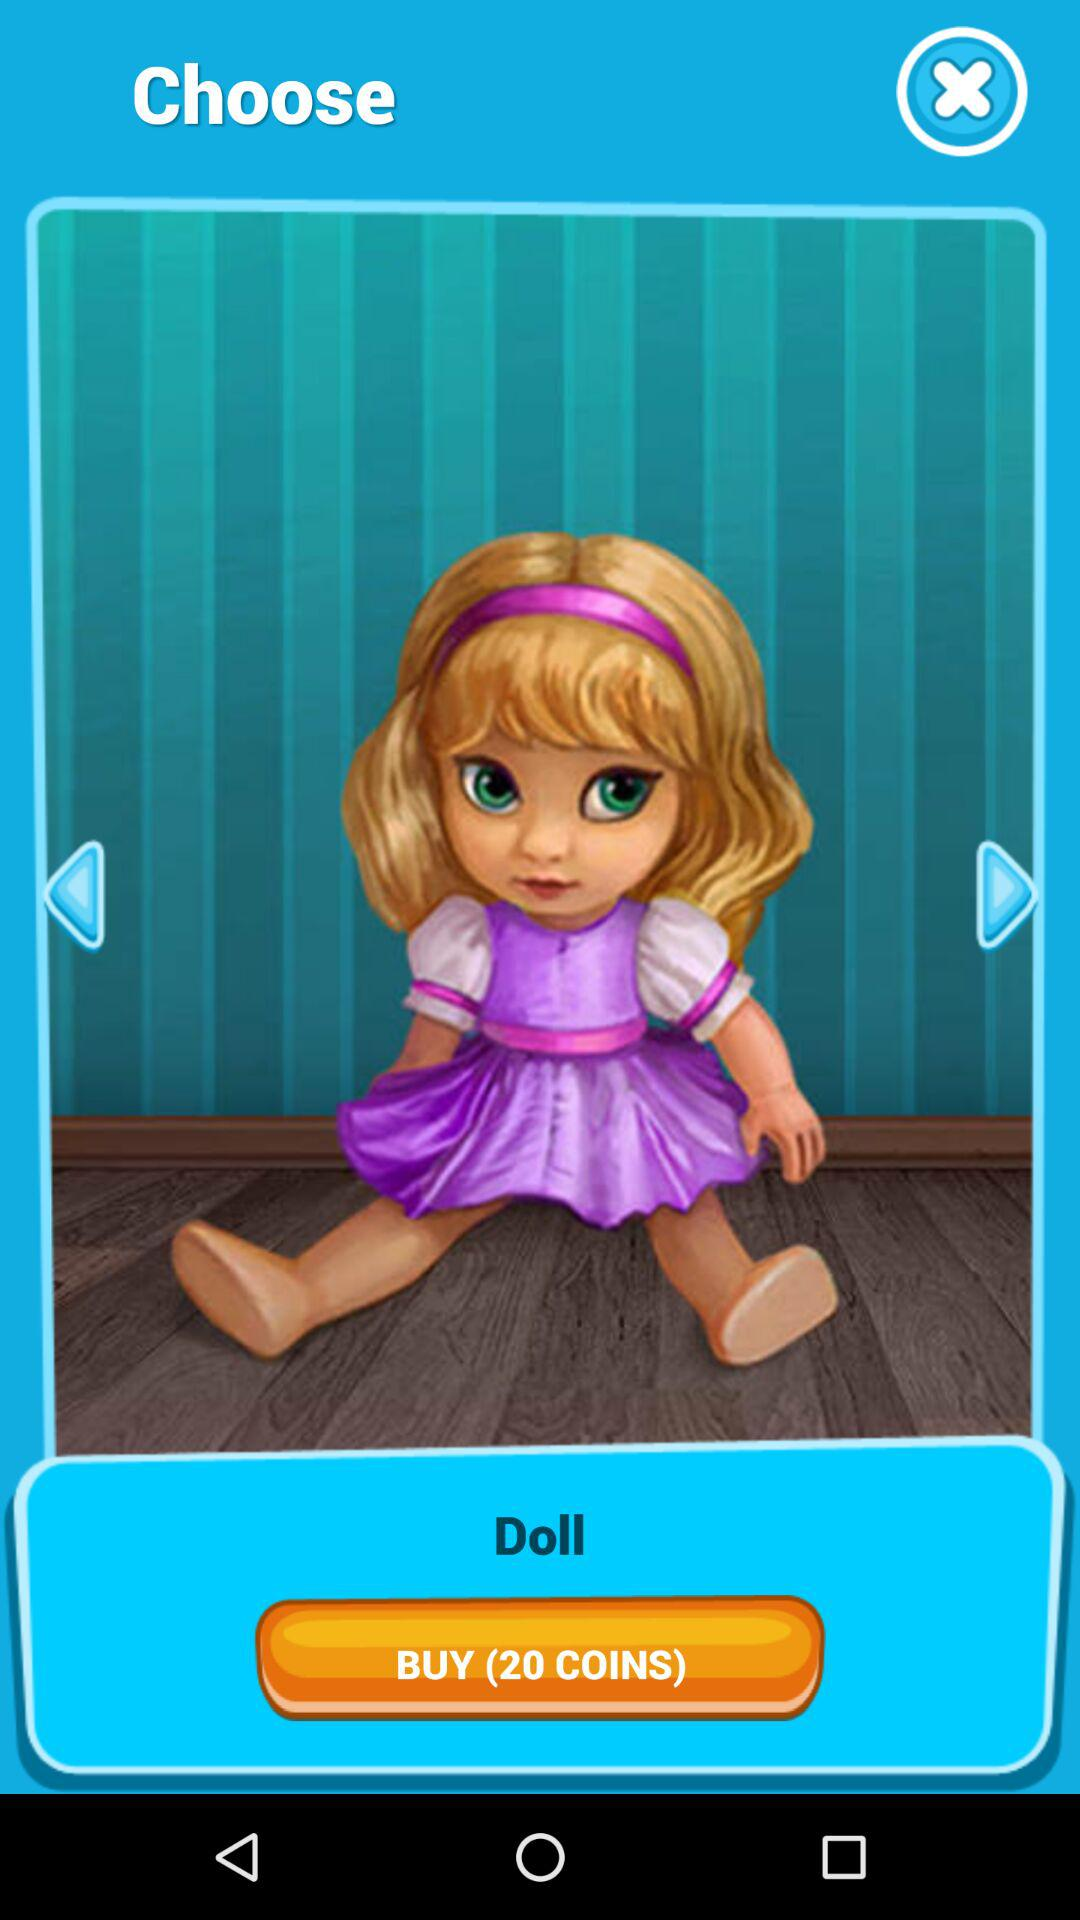How many coins are required to buy the doll? There are 20 coins required to buy the doll. 